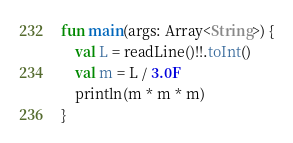<code> <loc_0><loc_0><loc_500><loc_500><_Kotlin_>fun main(args: Array<String>) {
    val L = readLine()!!.toInt()
    val m = L / 3.0F
    println(m * m * m)
}



</code> 